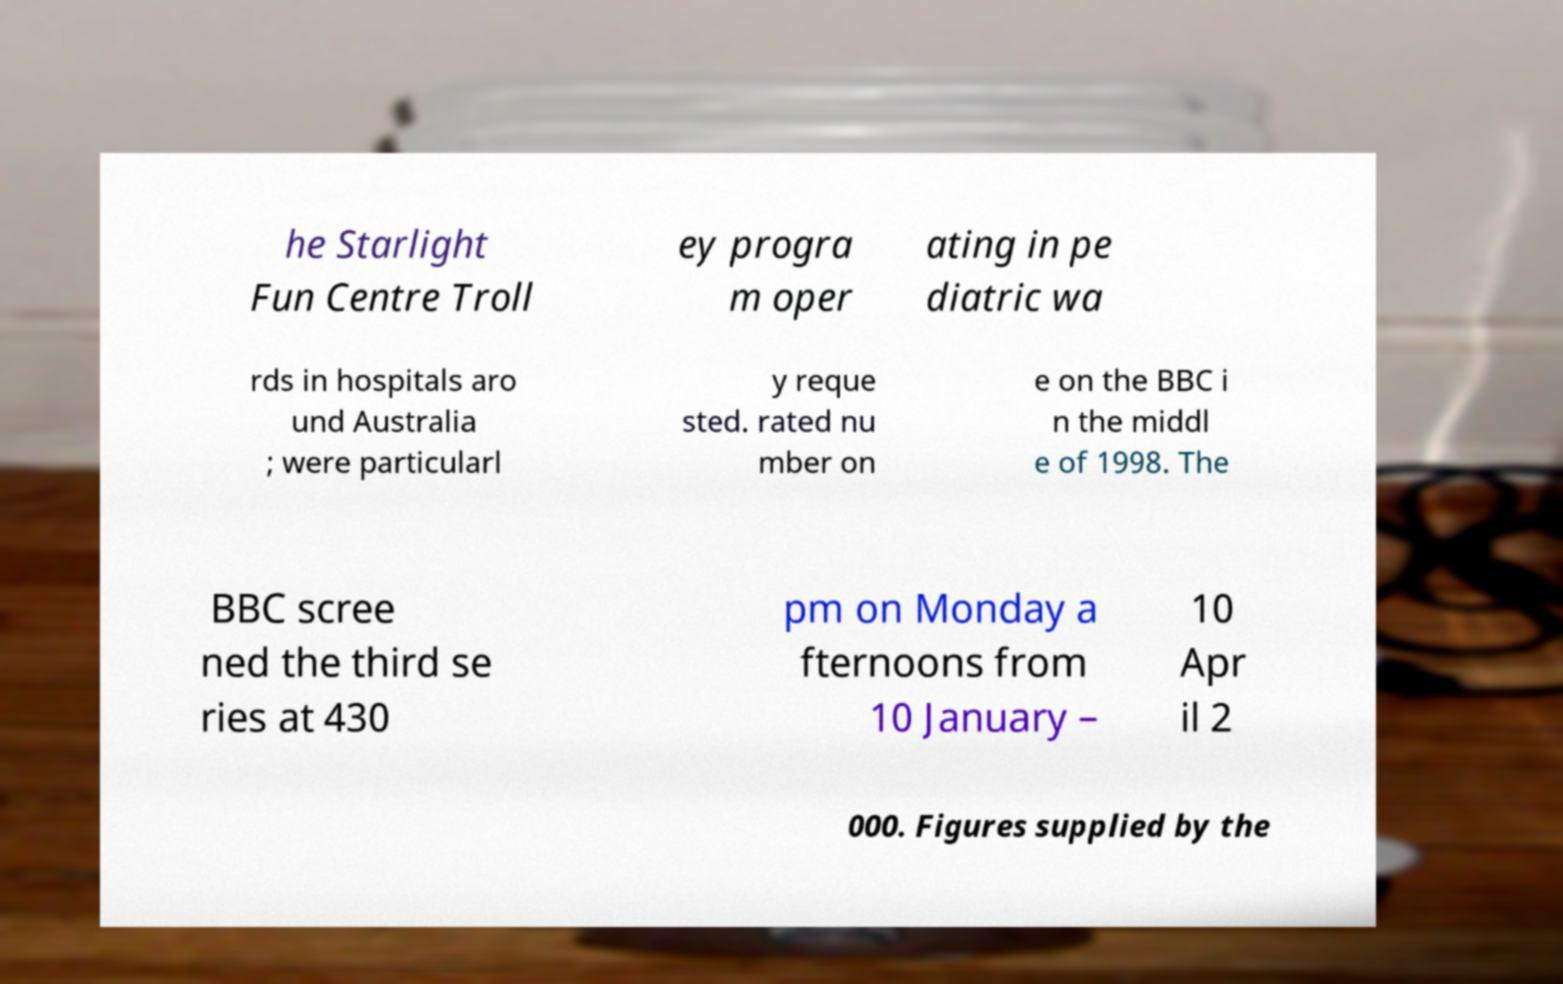I need the written content from this picture converted into text. Can you do that? he Starlight Fun Centre Troll ey progra m oper ating in pe diatric wa rds in hospitals aro und Australia ; were particularl y reque sted. rated nu mber on e on the BBC i n the middl e of 1998. The BBC scree ned the third se ries at 430 pm on Monday a fternoons from 10 January – 10 Apr il 2 000. Figures supplied by the 